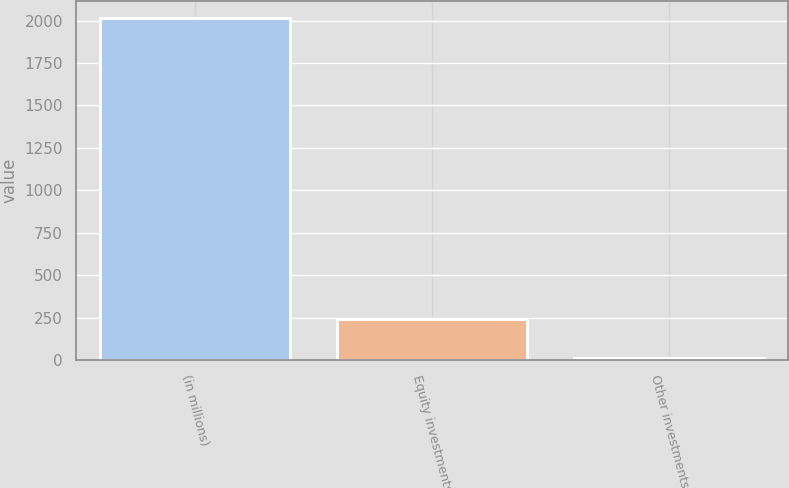<chart> <loc_0><loc_0><loc_500><loc_500><bar_chart><fcel>(in millions)<fcel>Equity investments<fcel>Other investments<nl><fcel>2013<fcel>245<fcel>15<nl></chart> 